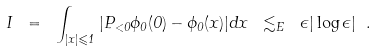<formula> <loc_0><loc_0><loc_500><loc_500>I \ = \ \int _ { | x | \leqslant 1 } | P _ { < 0 } \phi _ { 0 } ( 0 ) - \phi _ { 0 } ( x ) | d x \ \lesssim _ { E } \ \epsilon | \log \epsilon | \ .</formula> 